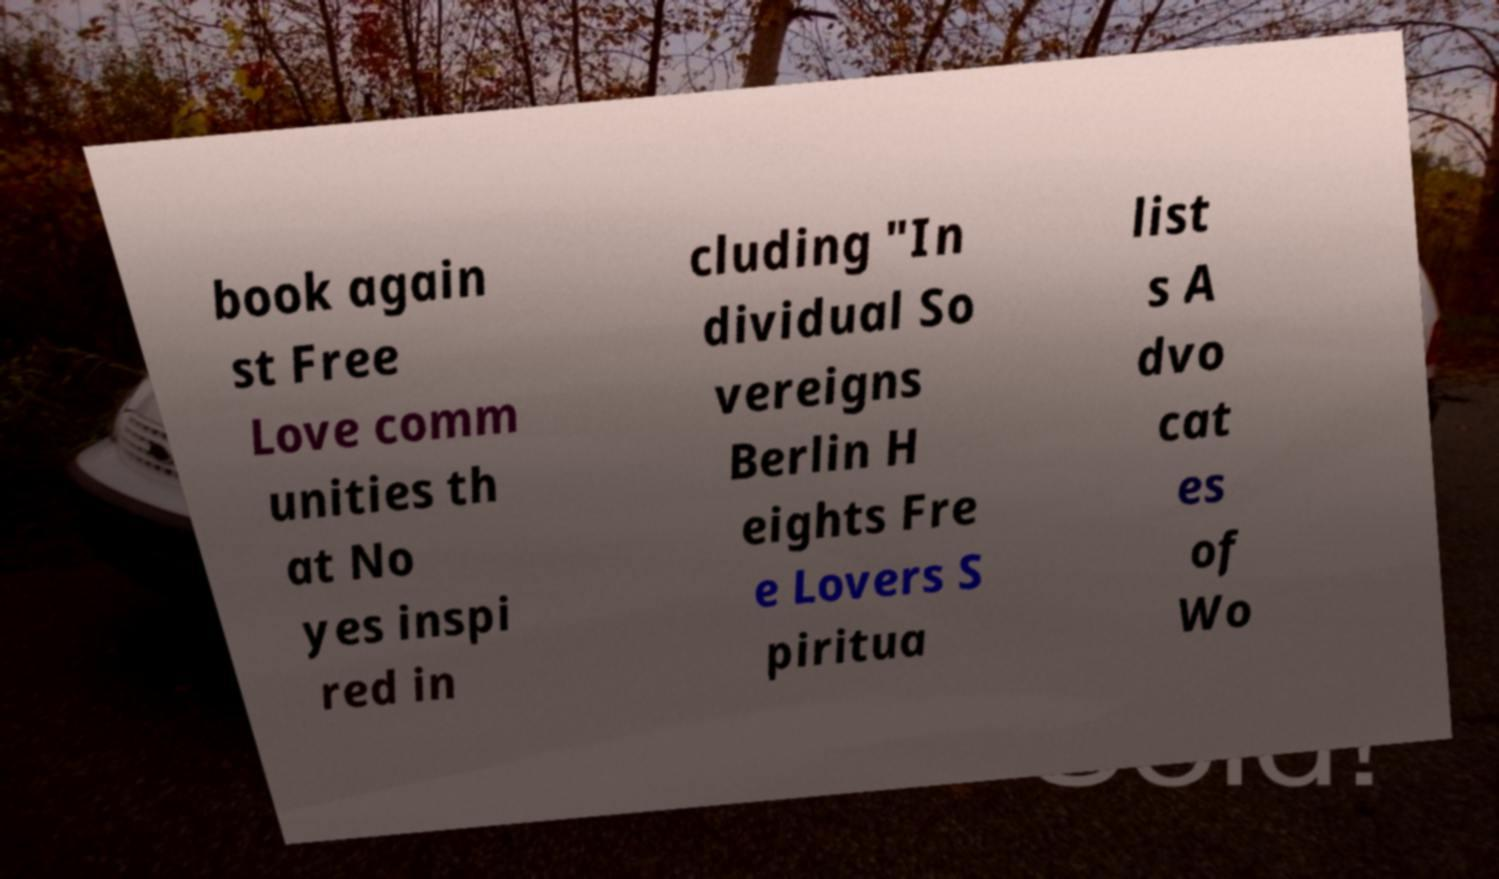Please read and relay the text visible in this image. What does it say? book again st Free Love comm unities th at No yes inspi red in cluding "In dividual So vereigns Berlin H eights Fre e Lovers S piritua list s A dvo cat es of Wo 